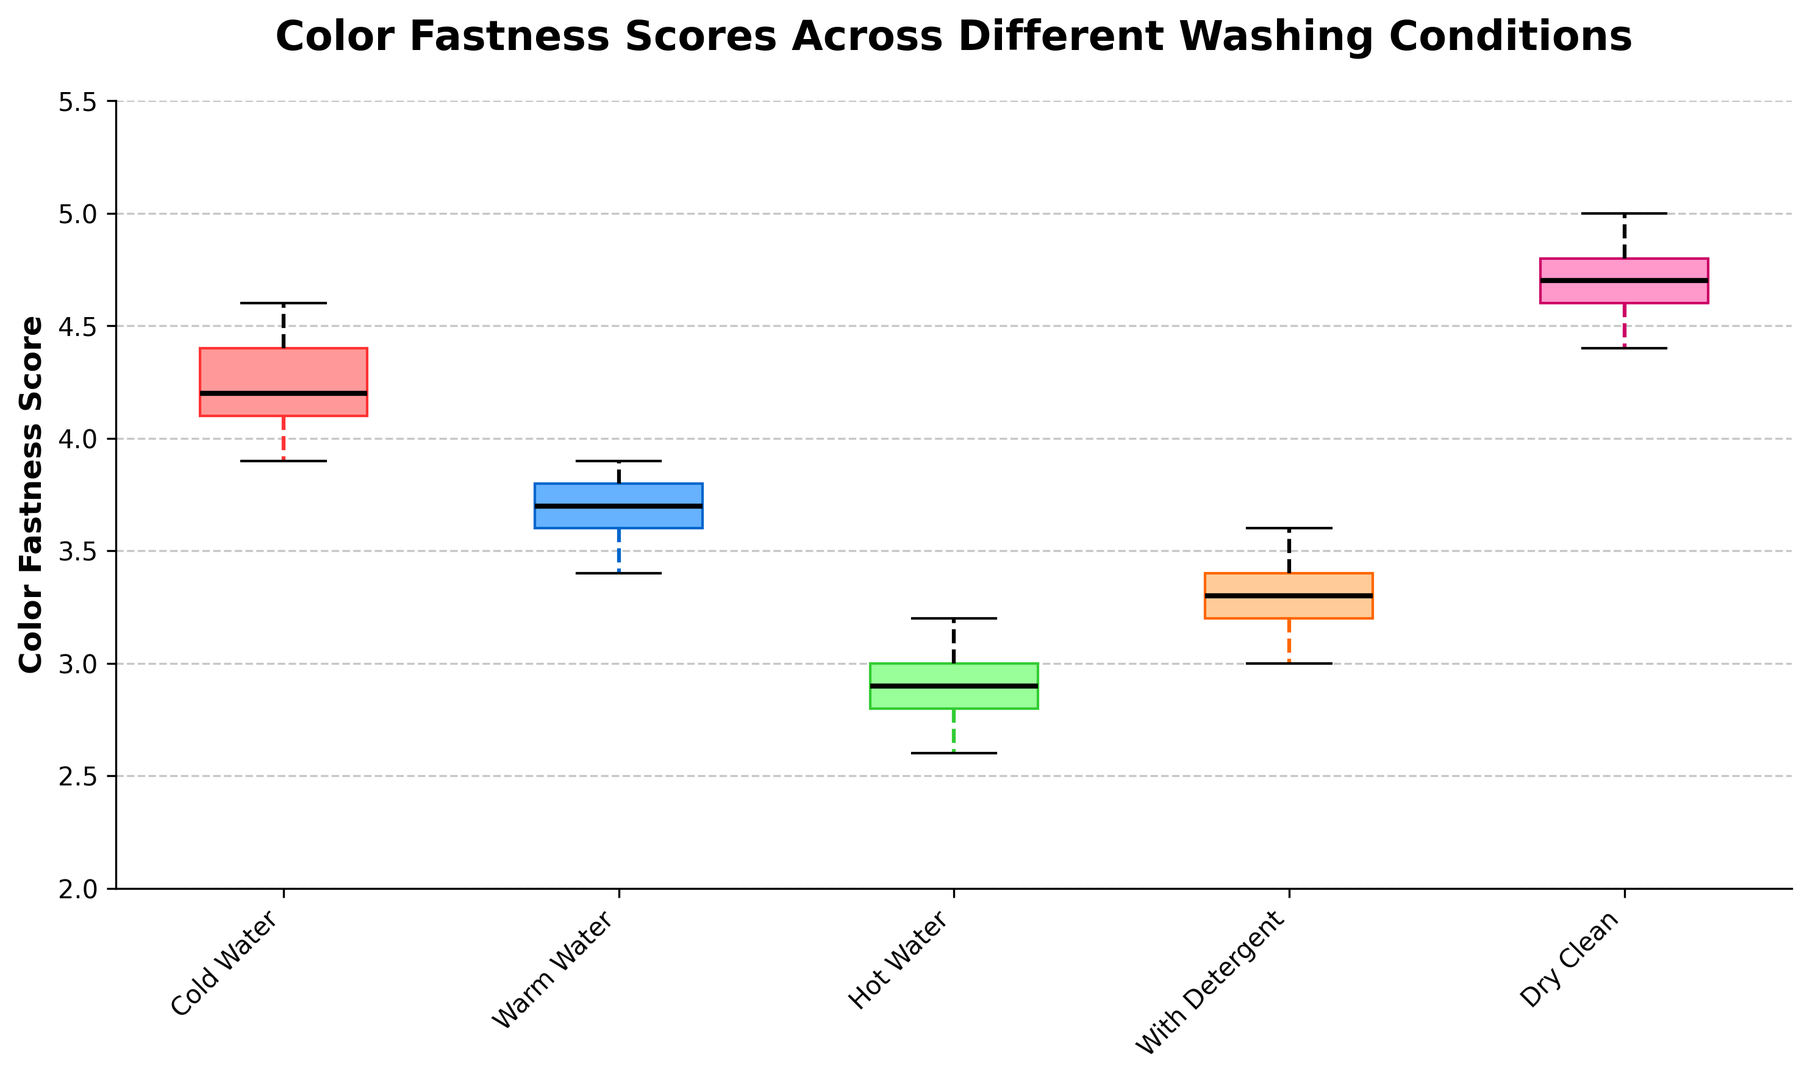What is the median color fastness score for textiles washed in cold water? The median is the middle value of the sorted data. For the "Cold Water" condition, the scores in ascending order are 3.9, 4.0, 4.1, 4.2, 4.2, 4.3, 4.4, 4.5, 4.6. The middle value is 4.2.
Answer: 4.2 Which washing condition resulted in the highest median color fastness score? By observing the boxplot, we see that the "Dry Clean" condition has the highest line in the middle of the box, indicating the highest median.
Answer: Dry Clean Compare the interquartile ranges (IQR) of "Warm Water" and "Hot Water". Which one is larger? The interquartile range is the difference between the third quartile (Q3) and the first quartile (Q1). The box for "Warm Water" is visually taller than that of "Hot Water", indicating a larger IQR.
Answer: Warm Water What is the range of color fastness scores for textiles washed with detergent? The range is the difference between the maximum and minimum values. For "With Detergent", the minimum score is 3.0, and the maximum is 3.6. So, the range is 3.6 - 3.0.
Answer: 0.6 How does the color fastness score variability compare between cold water and dry clean conditions? Variability can be inferred from the IQR and the range of whiskers. The box and whiskers for "Cold Water" are more spread out than for "Dry Clean", indicating higher variability in "Cold Water".
Answer: Cold Water shows higher variability Are there any outliers in the color fastness scores for "Warm Water"? Outliers are typically represented by dots or asterisks outside the whiskers. For "Warm Water", there are no such markers visible.
Answer: No How does the median color fastness score for "Hot Water" compare to that of "With Detergent"? The median is represented by the line inside the box. The line for "With Detergent" is higher than that for "Hot Water", indicating a higher median.
Answer: With Detergent has a higher median What is the color of the box representing "Dry Clean"? The box for "Dry Clean" is visually colored in a light pink shade.
Answer: Light pink Which washing condition has the smallest lower whisker value? The smallest lower whisker represents the lowest minimum value. Observing the plot, "Hot Water" has the lowest whisker.
Answer: Hot Water 